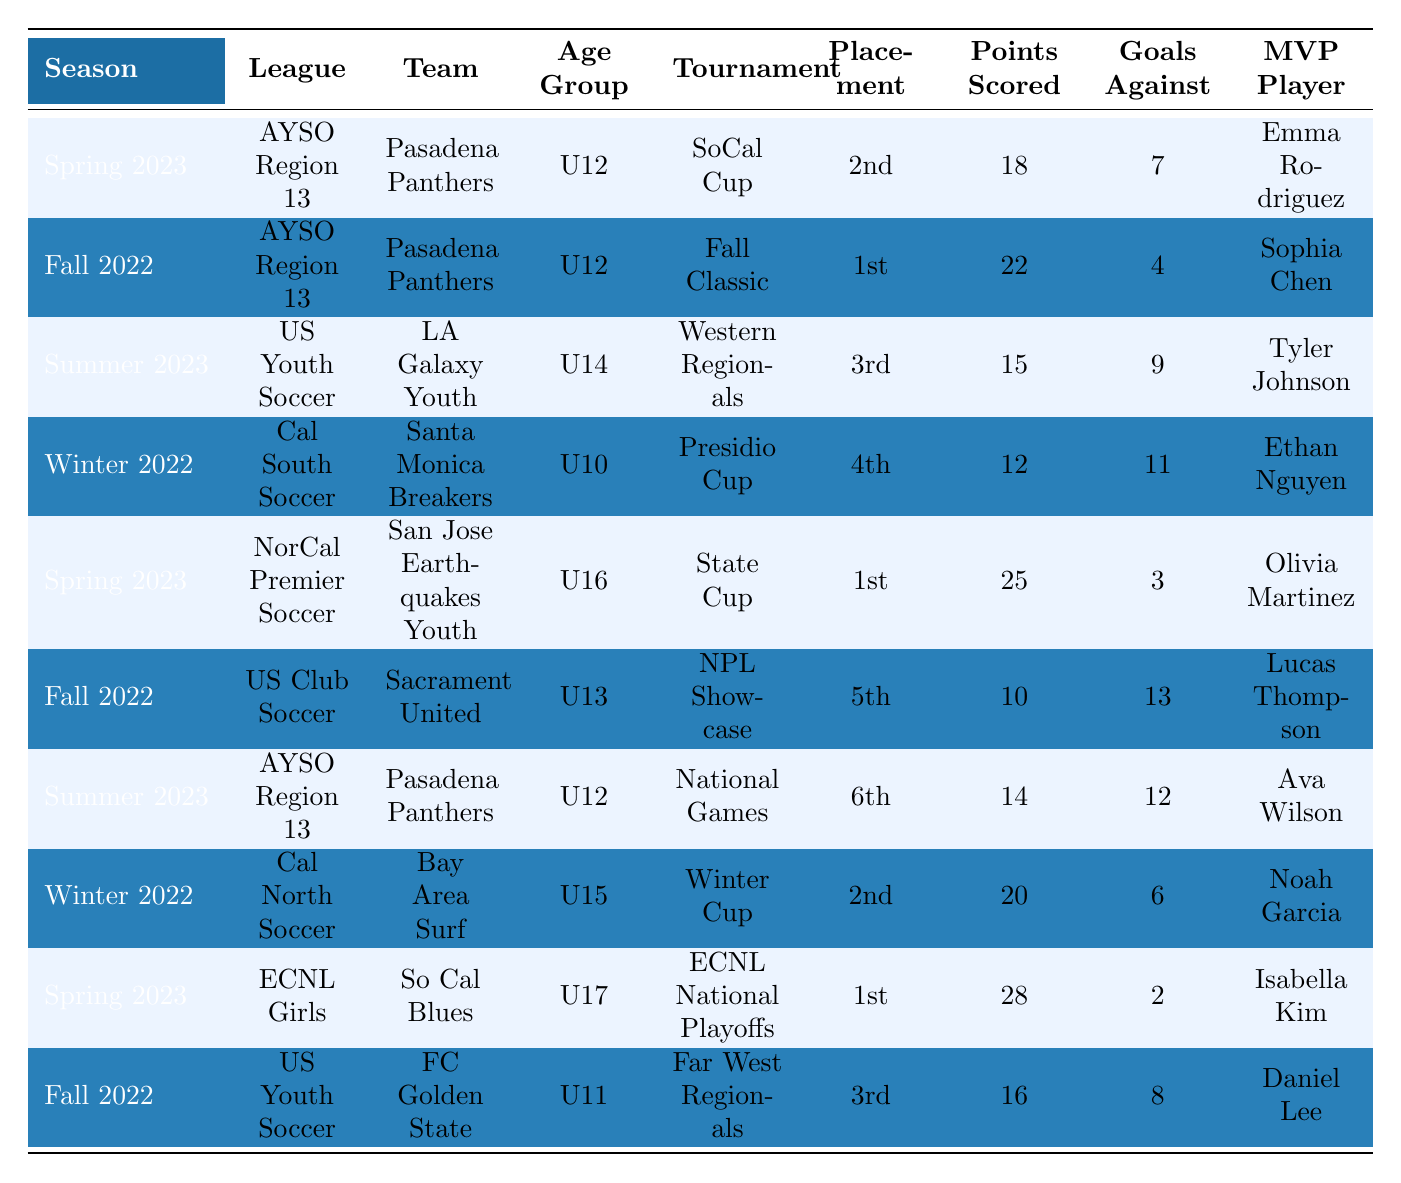What was the placement of the Pasadena Panthers in the Fall 2022 tournament? The table shows that the Pasadena Panthers participated in the Fall Classic tournament in Fall 2022 and placed 1st.
Answer: 1st Which team scored the highest points in their tournament? Looking at the table, the So Cal Blues achieved the highest points scored with 28 in the ECNL National Playoffs.
Answer: 28 How many goals did the Pasadena Panthers concede in the Summer 2023 National Games? The table indicates that in the Summer 2023 National Games, the Pasadena Panthers had goals against totaling 12.
Answer: 12 Did any U12 teams win their tournaments? The table reveals that the Pasadena Panthers in Fall 2022 won their tournament, and they are a U12 team.
Answer: Yes Which age group had the most teams represented in the tournaments? By counting the occurrences in the table, the U12 age group has three teams (Pasadena Panthers twice and FC Golden State) represented in the tournaments, more than any other age group.
Answer: U12 What was the average placement of the LA Galaxy Youth for their latest tournaments? LA Galaxy Youth placed 3rd in the Summer 2023 Western Regionals, and there is only one record for them, so the average placement is simply 3rd.
Answer: 3rd Was there any tournament where a U10 team placed higher than 4th? The table shows that the Santa Monica Breakers, a U10 team, placed 4th in the Presidio Cup, and no U10 team placed higher than that.
Answer: No Which team had the lowest placement in the tournaments and what was that placement? Reviewing the table, Sacramento United had the lowest placement of 5th in the NPL Showcase.
Answer: 5th How many points did the MVP player from the Spring 2023 State Cup score? The table indicates that Olivia Martinez was the MVP player for the San Jose Earthquakes Youth in the Spring 2023 State Cup, with the team scoring 25 points.
Answer: 25 Which tournament had the most significant difference in points scored and goals against for any team? The So Cal Blues scored 28 points and had 2 goals against, resulting in a difference of 26, which is the most significant difference in the table.
Answer: 26 